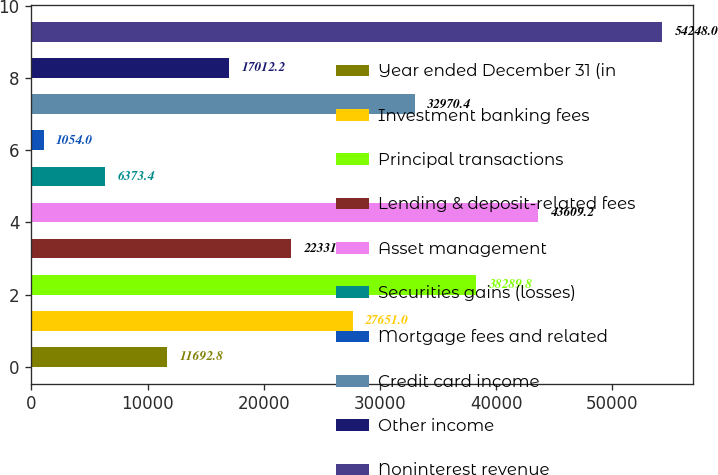Convert chart to OTSL. <chart><loc_0><loc_0><loc_500><loc_500><bar_chart><fcel>Year ended December 31 (in<fcel>Investment banking fees<fcel>Principal transactions<fcel>Lending & deposit-related fees<fcel>Asset management<fcel>Securities gains (losses)<fcel>Mortgage fees and related<fcel>Credit card income<fcel>Other income<fcel>Noninterest revenue<nl><fcel>11692.8<fcel>27651<fcel>38289.8<fcel>22331.6<fcel>43609.2<fcel>6373.4<fcel>1054<fcel>32970.4<fcel>17012.2<fcel>54248<nl></chart> 